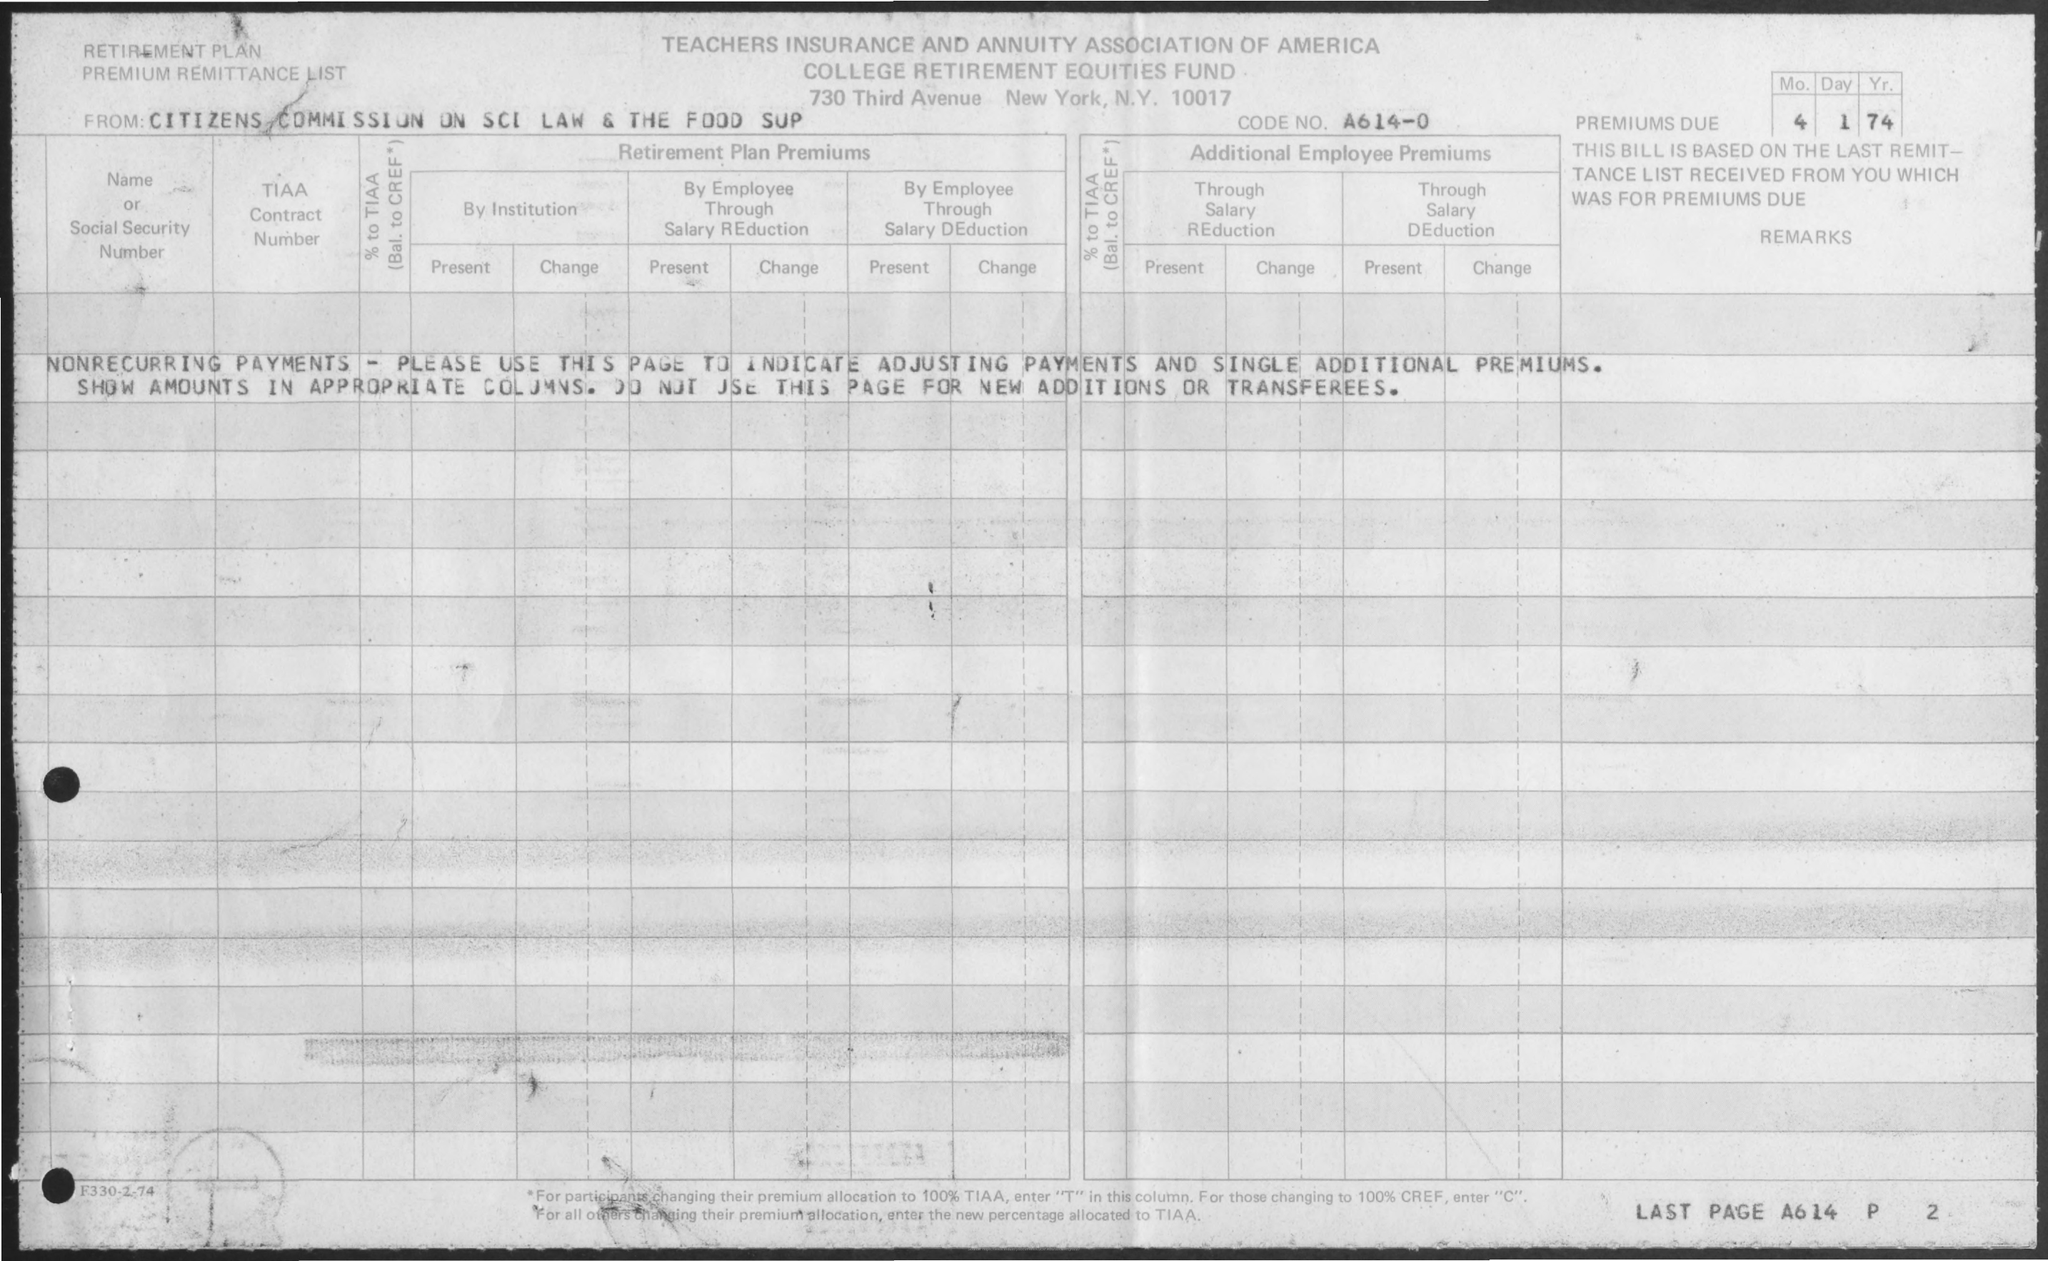What is the Code No.?
 A614-0 